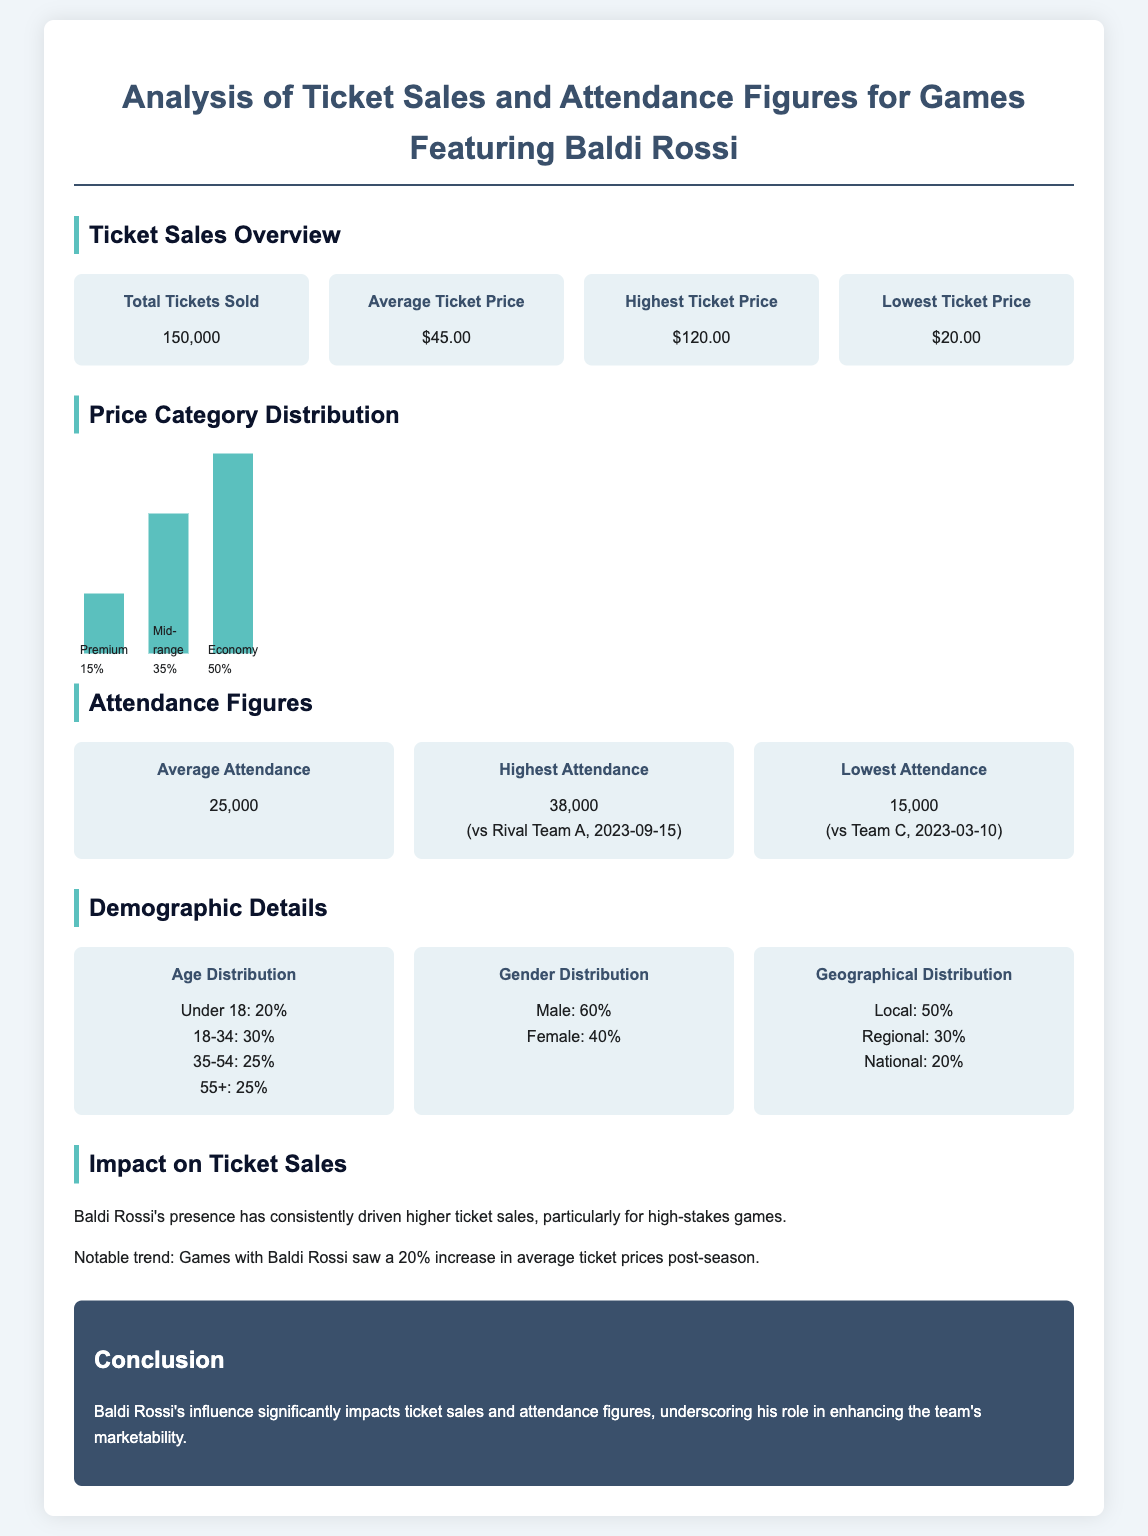what is the total number of tickets sold? The total number of tickets sold is specified in the document, which is 150,000.
Answer: 150,000 what is the average ticket price? The average ticket price is provided in the document, which is $45.00.
Answer: $45.00 what percentage of ticket sales are Economy tickets? The document indicates that Economy tickets account for 50% of ticket sales.
Answer: 50% what was the highest attendance recorded? The highest attendance recorded is mentioned in the document as 38,000.
Answer: 38,000 what is the age distribution percentage for those aged 18-34? The document states that 30% of attendees fall in the 18-34 age range.
Answer: 30% how much did ticket prices increase post-season? According to the document, ticket prices increased by 20% after the season.
Answer: 20% what proportion of attendees are male? The document states that male attendees make up 60% of the audience.
Answer: 60% what is the total attendance figure mentioned in the analysis? The average attendance figure provided in the document is 25,000.
Answer: 25,000 what is the demographic percentage of local attendees? The document specifies that 50% of attendees are local.
Answer: 50% 